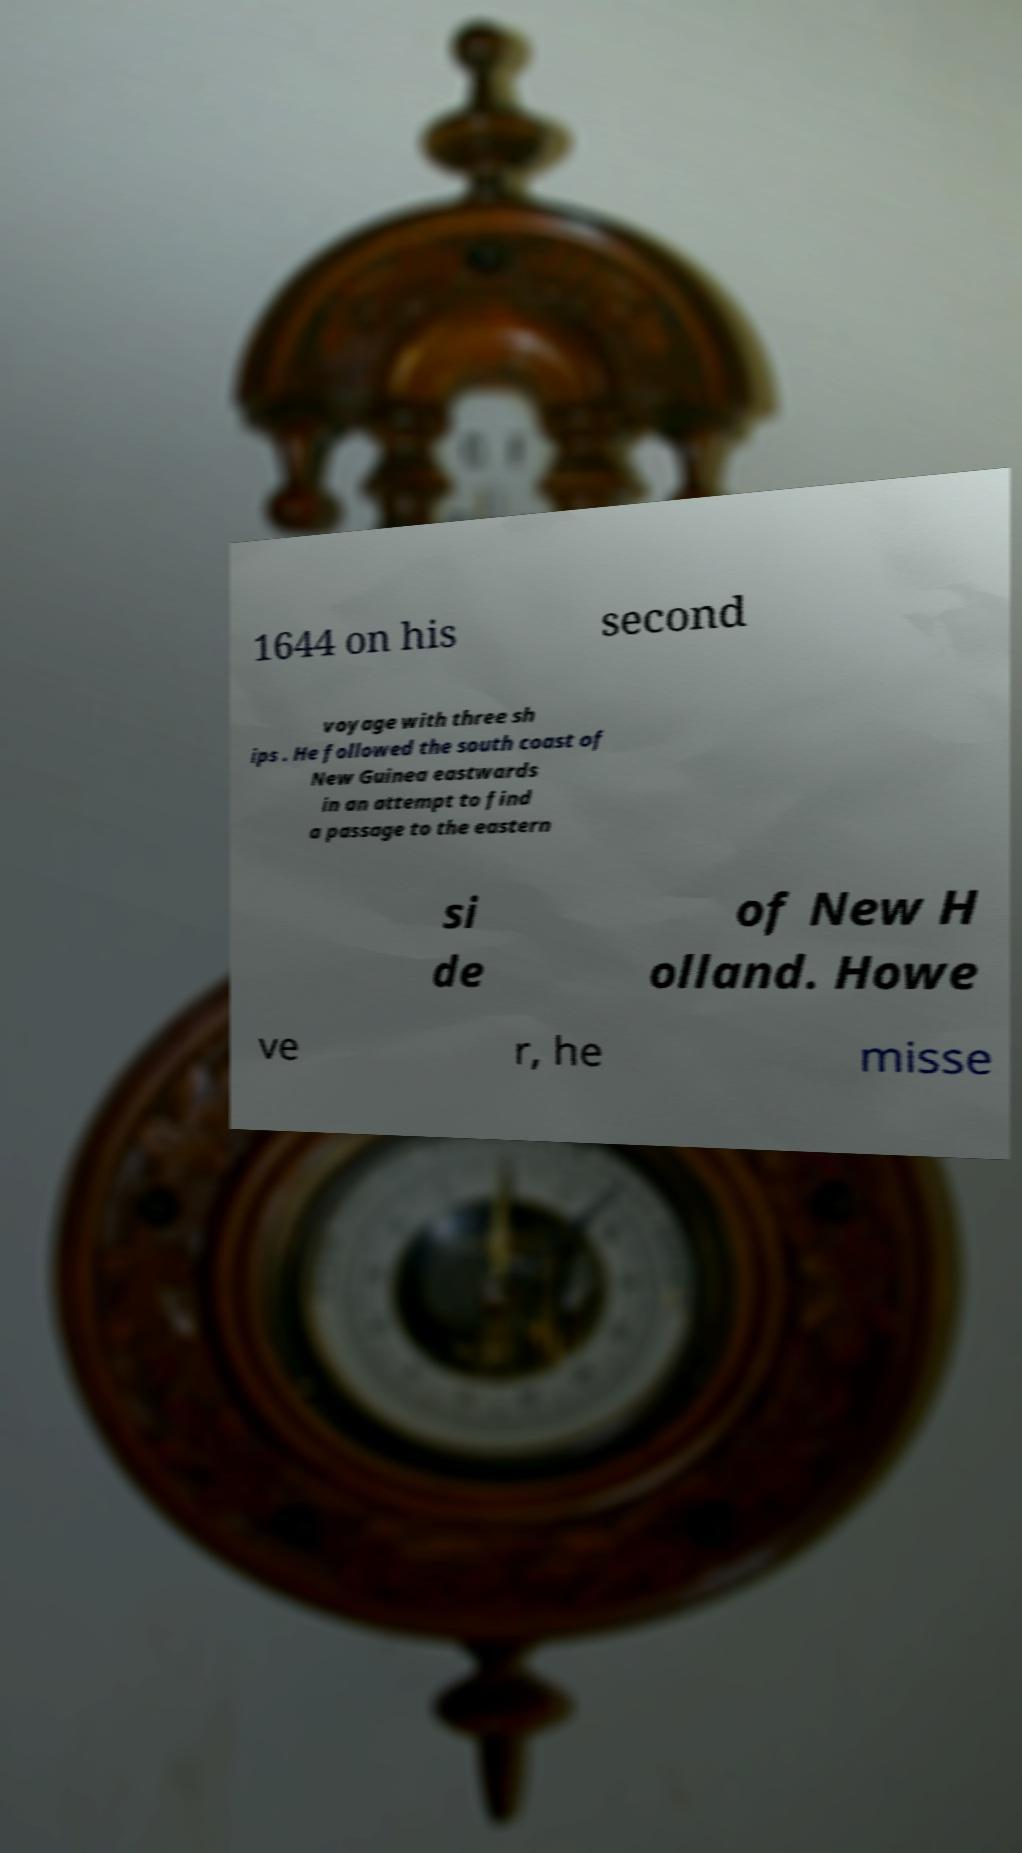I need the written content from this picture converted into text. Can you do that? 1644 on his second voyage with three sh ips . He followed the south coast of New Guinea eastwards in an attempt to find a passage to the eastern si de of New H olland. Howe ve r, he misse 